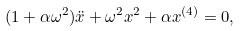Convert formula to latex. <formula><loc_0><loc_0><loc_500><loc_500>( 1 + \alpha \omega ^ { 2 } ) \ddot { x } + \omega ^ { 2 } x ^ { 2 } + \alpha x ^ { ( 4 ) } = 0 ,</formula> 